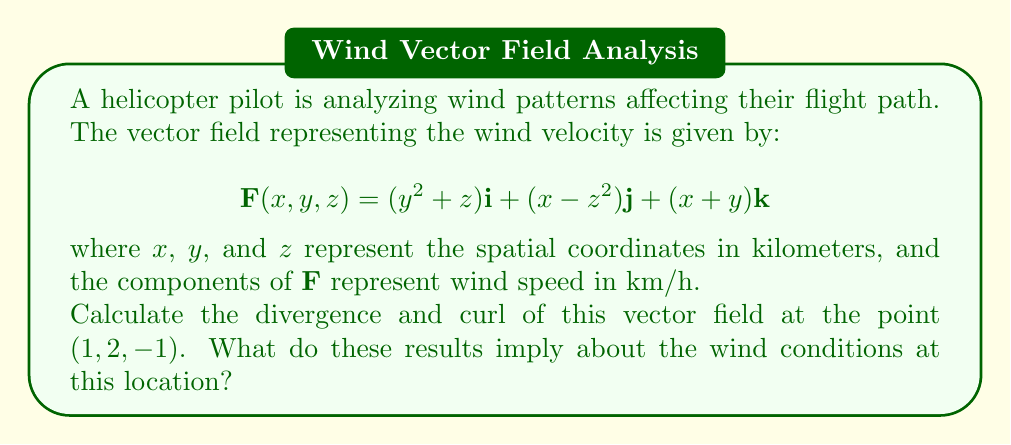What is the answer to this math problem? Let's approach this step-by-step:

1) First, let's recall the formulas for divergence and curl in 3D:

   Divergence: $\nabla \cdot \mathbf{F} = \frac{\partial F_x}{\partial x} + \frac{\partial F_y}{\partial y} + \frac{\partial F_z}{\partial z}$

   Curl: $\nabla \times \mathbf{F} = \left(\frac{\partial F_z}{\partial y} - \frac{\partial F_y}{\partial z}\right)\mathbf{i} + \left(\frac{\partial F_x}{\partial z} - \frac{\partial F_z}{\partial x}\right)\mathbf{j} + \left(\frac{\partial F_y}{\partial x} - \frac{\partial F_x}{\partial y}\right)\mathbf{k}$

2) Let's calculate the partial derivatives:

   $\frac{\partial F_x}{\partial x} = 0$
   $\frac{\partial F_x}{\partial y} = 2y$
   $\frac{\partial F_x}{\partial z} = 1$

   $\frac{\partial F_y}{\partial x} = 1$
   $\frac{\partial F_y}{\partial y} = 0$
   $\frac{\partial F_y}{\partial z} = -2z$

   $\frac{\partial F_z}{\partial x} = 1$
   $\frac{\partial F_z}{\partial y} = 1$
   $\frac{\partial F_z}{\partial z} = 0$

3) Now, let's calculate the divergence:

   $\nabla \cdot \mathbf{F} = \frac{\partial F_x}{\partial x} + \frac{\partial F_y}{\partial y} + \frac{\partial F_z}{\partial z} = 0 + 0 + 0 = 0$

4) Next, let's calculate the curl:

   $\nabla \times \mathbf{F} = (1 - (-2z))\mathbf{i} + (1 - 1)\mathbf{j} + (1 - 2y)\mathbf{k}$
                             $= (1 + 2z)\mathbf{i} + 0\mathbf{j} + (1 - 2y)\mathbf{k}$

5) Evaluating at the point (1, 2, -1):

   Divergence: $\nabla \cdot \mathbf{F} = 0$

   Curl: $\nabla \times \mathbf{F} = (1 + 2(-1))\mathbf{i} + 0\mathbf{j} + (1 - 2(2))\mathbf{k}$
                                   $= -1\mathbf{i} + 0\mathbf{j} - 3\mathbf{k}$

6) Interpretation:
   - The divergence being zero indicates that the wind field is incompressible at this point, meaning there's no net inflow or outflow of air.
   - The non-zero curl indicates that there is rotation in the wind field. The curl vector $(-1, 0, -3)$ gives the axis of rotation and its magnitude represents the strength of the rotation.
Answer: The divergence is 0, and the curl is $-\mathbf{i} - 3\mathbf{k}$ at the point (1, 2, -1). This implies that the wind field is incompressible at this point, with no net accumulation or depletion of air, but there is rotation present, primarily around the y-axis and to a lesser extent around the x-axis. 